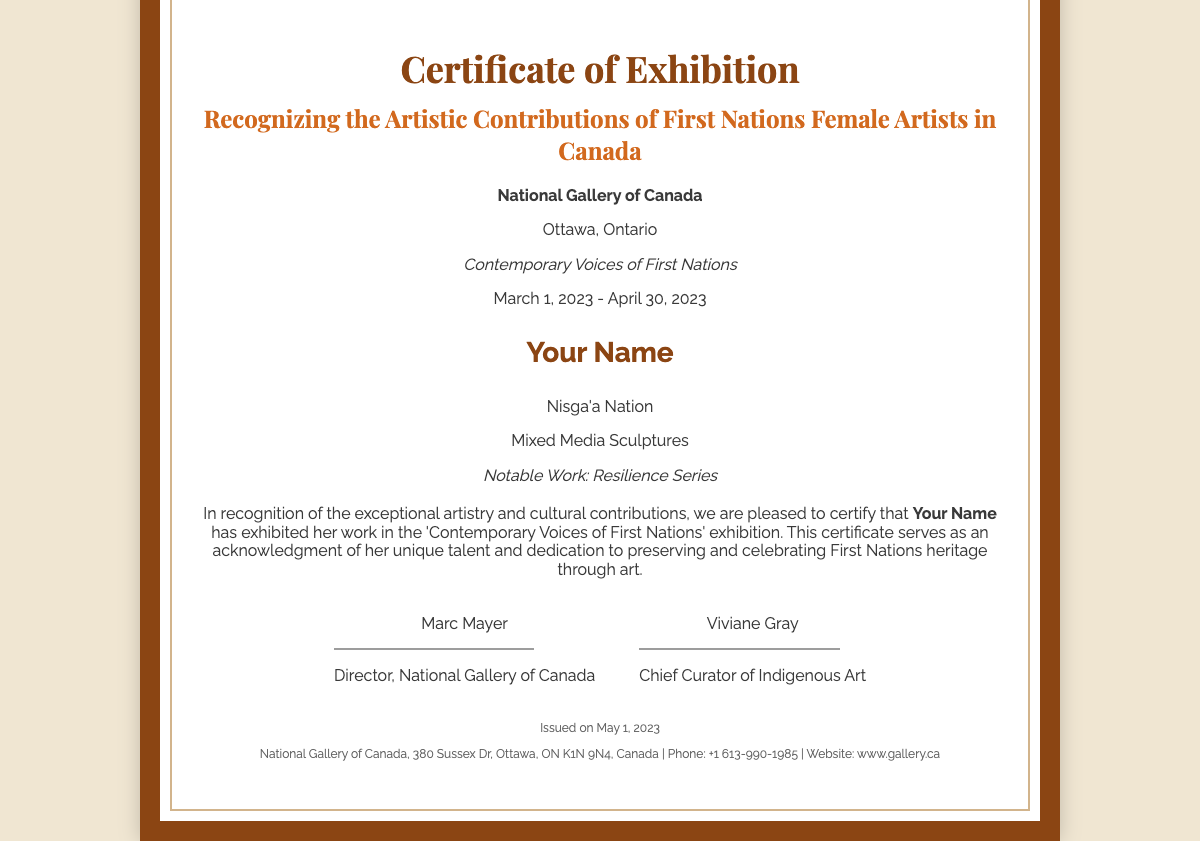what is the title of the certificate? The title of the certificate is located prominently at the top of the document.
Answer: Certificate of Exhibition who issued the certificate? The organization issuing the certificate is stated clearly.
Answer: National Gallery of Canada what is the date range of the exhibition? The date range of the exhibition is specified in the header section of the document.
Answer: March 1, 2023 - April 30, 2023 who is recognized in the certificate? The individual's name is mentioned in the artist details section.
Answer: Your Name what type of artwork did the artist showcase? The type of artwork is described under the artist details section.
Answer: Mixed Media Sculptures who are the signatories on the certificate? The certificate includes the names of two individuals who signed it as leaders of the gallery.
Answer: Marc Mayer, Viviane Gray how many signatures are on the certificate? The document contains a section for signatures, indicating the total count.
Answer: 2 what is the notable work of the artist? The notable work is mentioned as part of the artist's details.
Answer: Resilience Series where is the National Gallery of Canada located? The location of the gallery is provided in the footer of the document.
Answer: Ottawa, Ontario 